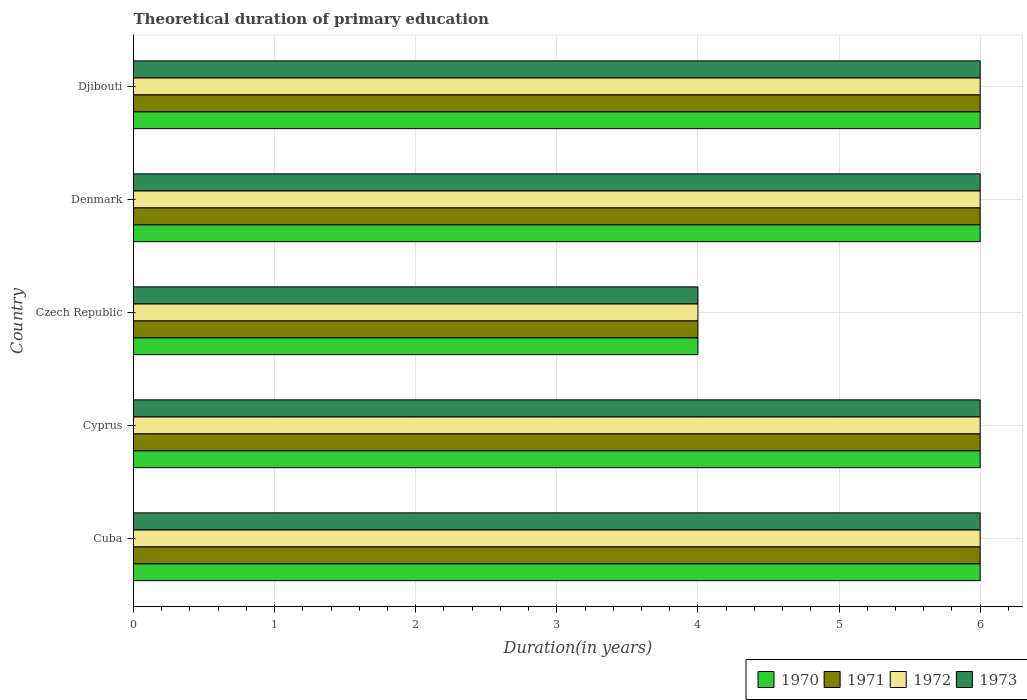How many different coloured bars are there?
Your answer should be very brief. 4. How many bars are there on the 4th tick from the top?
Provide a succinct answer. 4. What is the label of the 3rd group of bars from the top?
Offer a very short reply. Czech Republic. What is the total theoretical duration of primary education in 1970 in Djibouti?
Provide a short and direct response. 6. Across all countries, what is the maximum total theoretical duration of primary education in 1973?
Give a very brief answer. 6. In which country was the total theoretical duration of primary education in 1973 maximum?
Make the answer very short. Cuba. In which country was the total theoretical duration of primary education in 1971 minimum?
Provide a short and direct response. Czech Republic. What is the difference between the total theoretical duration of primary education in 1973 in Cyprus and that in Denmark?
Give a very brief answer. 0. What is the average total theoretical duration of primary education in 1973 per country?
Provide a succinct answer. 5.6. What is the ratio of the total theoretical duration of primary education in 1970 in Cuba to that in Cyprus?
Provide a succinct answer. 1. Is the difference between the total theoretical duration of primary education in 1970 in Czech Republic and Djibouti greater than the difference between the total theoretical duration of primary education in 1972 in Czech Republic and Djibouti?
Keep it short and to the point. No. What is the difference between the highest and the second highest total theoretical duration of primary education in 1972?
Keep it short and to the point. 0. Is it the case that in every country, the sum of the total theoretical duration of primary education in 1970 and total theoretical duration of primary education in 1972 is greater than the sum of total theoretical duration of primary education in 1973 and total theoretical duration of primary education in 1971?
Keep it short and to the point. No. What does the 4th bar from the top in Cuba represents?
Offer a very short reply. 1970. What does the 4th bar from the bottom in Djibouti represents?
Provide a succinct answer. 1973. Is it the case that in every country, the sum of the total theoretical duration of primary education in 1972 and total theoretical duration of primary education in 1971 is greater than the total theoretical duration of primary education in 1973?
Ensure brevity in your answer.  Yes. How many bars are there?
Your answer should be very brief. 20. What is the difference between two consecutive major ticks on the X-axis?
Offer a terse response. 1. Does the graph contain any zero values?
Keep it short and to the point. No. How are the legend labels stacked?
Provide a succinct answer. Horizontal. What is the title of the graph?
Provide a short and direct response. Theoretical duration of primary education. What is the label or title of the X-axis?
Give a very brief answer. Duration(in years). What is the label or title of the Y-axis?
Make the answer very short. Country. What is the Duration(in years) in 1970 in Cuba?
Your response must be concise. 6. What is the Duration(in years) in 1973 in Cuba?
Offer a very short reply. 6. What is the Duration(in years) in 1972 in Cyprus?
Your response must be concise. 6. What is the Duration(in years) in 1970 in Czech Republic?
Offer a very short reply. 4. What is the Duration(in years) of 1971 in Czech Republic?
Give a very brief answer. 4. What is the Duration(in years) of 1971 in Denmark?
Keep it short and to the point. 6. What is the Duration(in years) of 1973 in Denmark?
Provide a succinct answer. 6. Across all countries, what is the maximum Duration(in years) in 1972?
Your answer should be very brief. 6. Across all countries, what is the maximum Duration(in years) of 1973?
Your answer should be very brief. 6. Across all countries, what is the minimum Duration(in years) in 1970?
Give a very brief answer. 4. What is the total Duration(in years) of 1970 in the graph?
Your answer should be compact. 28. What is the total Duration(in years) of 1971 in the graph?
Your answer should be very brief. 28. What is the difference between the Duration(in years) in 1973 in Cuba and that in Cyprus?
Ensure brevity in your answer.  0. What is the difference between the Duration(in years) of 1970 in Cuba and that in Czech Republic?
Ensure brevity in your answer.  2. What is the difference between the Duration(in years) of 1971 in Cuba and that in Czech Republic?
Provide a succinct answer. 2. What is the difference between the Duration(in years) in 1973 in Cuba and that in Czech Republic?
Provide a succinct answer. 2. What is the difference between the Duration(in years) in 1970 in Cuba and that in Denmark?
Make the answer very short. 0. What is the difference between the Duration(in years) in 1973 in Cuba and that in Denmark?
Your answer should be compact. 0. What is the difference between the Duration(in years) of 1970 in Cuba and that in Djibouti?
Make the answer very short. 0. What is the difference between the Duration(in years) in 1973 in Cuba and that in Djibouti?
Your answer should be compact. 0. What is the difference between the Duration(in years) in 1971 in Cyprus and that in Czech Republic?
Give a very brief answer. 2. What is the difference between the Duration(in years) in 1972 in Cyprus and that in Czech Republic?
Give a very brief answer. 2. What is the difference between the Duration(in years) of 1973 in Cyprus and that in Czech Republic?
Your response must be concise. 2. What is the difference between the Duration(in years) in 1971 in Cyprus and that in Denmark?
Offer a very short reply. 0. What is the difference between the Duration(in years) in 1973 in Cyprus and that in Denmark?
Your answer should be compact. 0. What is the difference between the Duration(in years) in 1971 in Cyprus and that in Djibouti?
Ensure brevity in your answer.  0. What is the difference between the Duration(in years) in 1970 in Czech Republic and that in Denmark?
Provide a short and direct response. -2. What is the difference between the Duration(in years) in 1971 in Czech Republic and that in Denmark?
Give a very brief answer. -2. What is the difference between the Duration(in years) of 1973 in Czech Republic and that in Denmark?
Your response must be concise. -2. What is the difference between the Duration(in years) in 1970 in Czech Republic and that in Djibouti?
Make the answer very short. -2. What is the difference between the Duration(in years) of 1971 in Czech Republic and that in Djibouti?
Your answer should be compact. -2. What is the difference between the Duration(in years) of 1970 in Denmark and that in Djibouti?
Ensure brevity in your answer.  0. What is the difference between the Duration(in years) in 1971 in Denmark and that in Djibouti?
Your answer should be compact. 0. What is the difference between the Duration(in years) of 1973 in Denmark and that in Djibouti?
Your answer should be very brief. 0. What is the difference between the Duration(in years) of 1970 in Cuba and the Duration(in years) of 1972 in Cyprus?
Make the answer very short. 0. What is the difference between the Duration(in years) of 1970 in Cuba and the Duration(in years) of 1973 in Cyprus?
Provide a short and direct response. 0. What is the difference between the Duration(in years) of 1971 in Cuba and the Duration(in years) of 1972 in Cyprus?
Offer a terse response. 0. What is the difference between the Duration(in years) in 1972 in Cuba and the Duration(in years) in 1973 in Cyprus?
Keep it short and to the point. 0. What is the difference between the Duration(in years) of 1970 in Cuba and the Duration(in years) of 1971 in Czech Republic?
Ensure brevity in your answer.  2. What is the difference between the Duration(in years) in 1970 in Cuba and the Duration(in years) in 1972 in Czech Republic?
Keep it short and to the point. 2. What is the difference between the Duration(in years) of 1970 in Cuba and the Duration(in years) of 1973 in Czech Republic?
Provide a short and direct response. 2. What is the difference between the Duration(in years) of 1971 in Cuba and the Duration(in years) of 1972 in Czech Republic?
Give a very brief answer. 2. What is the difference between the Duration(in years) in 1971 in Cuba and the Duration(in years) in 1973 in Czech Republic?
Make the answer very short. 2. What is the difference between the Duration(in years) of 1972 in Cuba and the Duration(in years) of 1973 in Czech Republic?
Offer a very short reply. 2. What is the difference between the Duration(in years) in 1970 in Cuba and the Duration(in years) in 1971 in Denmark?
Offer a terse response. 0. What is the difference between the Duration(in years) of 1970 in Cuba and the Duration(in years) of 1972 in Denmark?
Ensure brevity in your answer.  0. What is the difference between the Duration(in years) in 1971 in Cuba and the Duration(in years) in 1972 in Denmark?
Make the answer very short. 0. What is the difference between the Duration(in years) of 1971 in Cuba and the Duration(in years) of 1973 in Denmark?
Keep it short and to the point. 0. What is the difference between the Duration(in years) of 1972 in Cuba and the Duration(in years) of 1973 in Denmark?
Provide a short and direct response. 0. What is the difference between the Duration(in years) of 1970 in Cuba and the Duration(in years) of 1972 in Djibouti?
Your response must be concise. 0. What is the difference between the Duration(in years) in 1971 in Cuba and the Duration(in years) in 1972 in Djibouti?
Your response must be concise. 0. What is the difference between the Duration(in years) of 1970 in Cyprus and the Duration(in years) of 1971 in Denmark?
Give a very brief answer. 0. What is the difference between the Duration(in years) in 1970 in Cyprus and the Duration(in years) in 1972 in Denmark?
Your answer should be compact. 0. What is the difference between the Duration(in years) in 1970 in Cyprus and the Duration(in years) in 1973 in Denmark?
Provide a succinct answer. 0. What is the difference between the Duration(in years) in 1971 in Cyprus and the Duration(in years) in 1973 in Denmark?
Make the answer very short. 0. What is the difference between the Duration(in years) in 1972 in Cyprus and the Duration(in years) in 1973 in Denmark?
Offer a very short reply. 0. What is the difference between the Duration(in years) of 1970 in Cyprus and the Duration(in years) of 1972 in Djibouti?
Give a very brief answer. 0. What is the difference between the Duration(in years) in 1970 in Cyprus and the Duration(in years) in 1973 in Djibouti?
Give a very brief answer. 0. What is the difference between the Duration(in years) of 1971 in Cyprus and the Duration(in years) of 1973 in Djibouti?
Ensure brevity in your answer.  0. What is the difference between the Duration(in years) in 1972 in Cyprus and the Duration(in years) in 1973 in Djibouti?
Your response must be concise. 0. What is the difference between the Duration(in years) of 1970 in Czech Republic and the Duration(in years) of 1971 in Denmark?
Provide a short and direct response. -2. What is the difference between the Duration(in years) of 1970 in Czech Republic and the Duration(in years) of 1972 in Denmark?
Make the answer very short. -2. What is the difference between the Duration(in years) in 1970 in Czech Republic and the Duration(in years) in 1973 in Denmark?
Your answer should be compact. -2. What is the difference between the Duration(in years) of 1972 in Czech Republic and the Duration(in years) of 1973 in Denmark?
Ensure brevity in your answer.  -2. What is the difference between the Duration(in years) of 1971 in Czech Republic and the Duration(in years) of 1972 in Djibouti?
Give a very brief answer. -2. What is the difference between the Duration(in years) in 1971 in Czech Republic and the Duration(in years) in 1973 in Djibouti?
Offer a terse response. -2. What is the difference between the Duration(in years) in 1970 in Denmark and the Duration(in years) in 1972 in Djibouti?
Provide a short and direct response. 0. What is the difference between the Duration(in years) in 1970 in Denmark and the Duration(in years) in 1973 in Djibouti?
Your answer should be compact. 0. What is the difference between the Duration(in years) of 1971 in Denmark and the Duration(in years) of 1973 in Djibouti?
Offer a very short reply. 0. What is the average Duration(in years) of 1971 per country?
Offer a terse response. 5.6. What is the difference between the Duration(in years) of 1970 and Duration(in years) of 1972 in Cuba?
Provide a succinct answer. 0. What is the difference between the Duration(in years) of 1971 and Duration(in years) of 1972 in Cuba?
Your answer should be very brief. 0. What is the difference between the Duration(in years) in 1970 and Duration(in years) in 1971 in Cyprus?
Provide a short and direct response. 0. What is the difference between the Duration(in years) in 1970 and Duration(in years) in 1972 in Cyprus?
Give a very brief answer. 0. What is the difference between the Duration(in years) in 1971 and Duration(in years) in 1972 in Cyprus?
Your answer should be compact. 0. What is the difference between the Duration(in years) in 1971 and Duration(in years) in 1973 in Cyprus?
Provide a succinct answer. 0. What is the difference between the Duration(in years) of 1970 and Duration(in years) of 1972 in Czech Republic?
Keep it short and to the point. 0. What is the difference between the Duration(in years) of 1970 and Duration(in years) of 1973 in Czech Republic?
Offer a very short reply. 0. What is the difference between the Duration(in years) of 1971 and Duration(in years) of 1972 in Czech Republic?
Provide a short and direct response. 0. What is the difference between the Duration(in years) of 1972 and Duration(in years) of 1973 in Czech Republic?
Give a very brief answer. 0. What is the difference between the Duration(in years) of 1970 and Duration(in years) of 1972 in Denmark?
Keep it short and to the point. 0. What is the difference between the Duration(in years) in 1970 and Duration(in years) in 1973 in Denmark?
Offer a very short reply. 0. What is the difference between the Duration(in years) of 1971 and Duration(in years) of 1973 in Denmark?
Your answer should be compact. 0. What is the difference between the Duration(in years) of 1972 and Duration(in years) of 1973 in Denmark?
Your response must be concise. 0. What is the difference between the Duration(in years) of 1970 and Duration(in years) of 1971 in Djibouti?
Keep it short and to the point. 0. What is the difference between the Duration(in years) in 1970 and Duration(in years) in 1972 in Djibouti?
Offer a terse response. 0. What is the difference between the Duration(in years) in 1970 and Duration(in years) in 1973 in Djibouti?
Your answer should be compact. 0. What is the difference between the Duration(in years) in 1971 and Duration(in years) in 1972 in Djibouti?
Make the answer very short. 0. What is the difference between the Duration(in years) of 1972 and Duration(in years) of 1973 in Djibouti?
Give a very brief answer. 0. What is the ratio of the Duration(in years) of 1970 in Cuba to that in Cyprus?
Your response must be concise. 1. What is the ratio of the Duration(in years) in 1972 in Cuba to that in Cyprus?
Give a very brief answer. 1. What is the ratio of the Duration(in years) in 1970 in Cuba to that in Denmark?
Offer a terse response. 1. What is the ratio of the Duration(in years) in 1971 in Cuba to that in Denmark?
Provide a succinct answer. 1. What is the ratio of the Duration(in years) in 1970 in Cuba to that in Djibouti?
Offer a very short reply. 1. What is the ratio of the Duration(in years) of 1971 in Cuba to that in Djibouti?
Ensure brevity in your answer.  1. What is the ratio of the Duration(in years) in 1973 in Cuba to that in Djibouti?
Offer a terse response. 1. What is the ratio of the Duration(in years) of 1972 in Cyprus to that in Czech Republic?
Keep it short and to the point. 1.5. What is the ratio of the Duration(in years) in 1970 in Cyprus to that in Denmark?
Offer a terse response. 1. What is the ratio of the Duration(in years) in 1970 in Cyprus to that in Djibouti?
Your answer should be compact. 1. What is the ratio of the Duration(in years) in 1971 in Czech Republic to that in Denmark?
Ensure brevity in your answer.  0.67. What is the ratio of the Duration(in years) in 1972 in Czech Republic to that in Denmark?
Offer a terse response. 0.67. What is the ratio of the Duration(in years) in 1971 in Czech Republic to that in Djibouti?
Your response must be concise. 0.67. What is the ratio of the Duration(in years) in 1970 in Denmark to that in Djibouti?
Give a very brief answer. 1. What is the ratio of the Duration(in years) in 1972 in Denmark to that in Djibouti?
Offer a very short reply. 1. What is the ratio of the Duration(in years) of 1973 in Denmark to that in Djibouti?
Give a very brief answer. 1. What is the difference between the highest and the second highest Duration(in years) of 1971?
Offer a terse response. 0. What is the difference between the highest and the second highest Duration(in years) of 1972?
Offer a very short reply. 0. What is the difference between the highest and the second highest Duration(in years) of 1973?
Your answer should be very brief. 0. What is the difference between the highest and the lowest Duration(in years) in 1970?
Make the answer very short. 2. What is the difference between the highest and the lowest Duration(in years) of 1972?
Your answer should be very brief. 2. What is the difference between the highest and the lowest Duration(in years) of 1973?
Offer a very short reply. 2. 